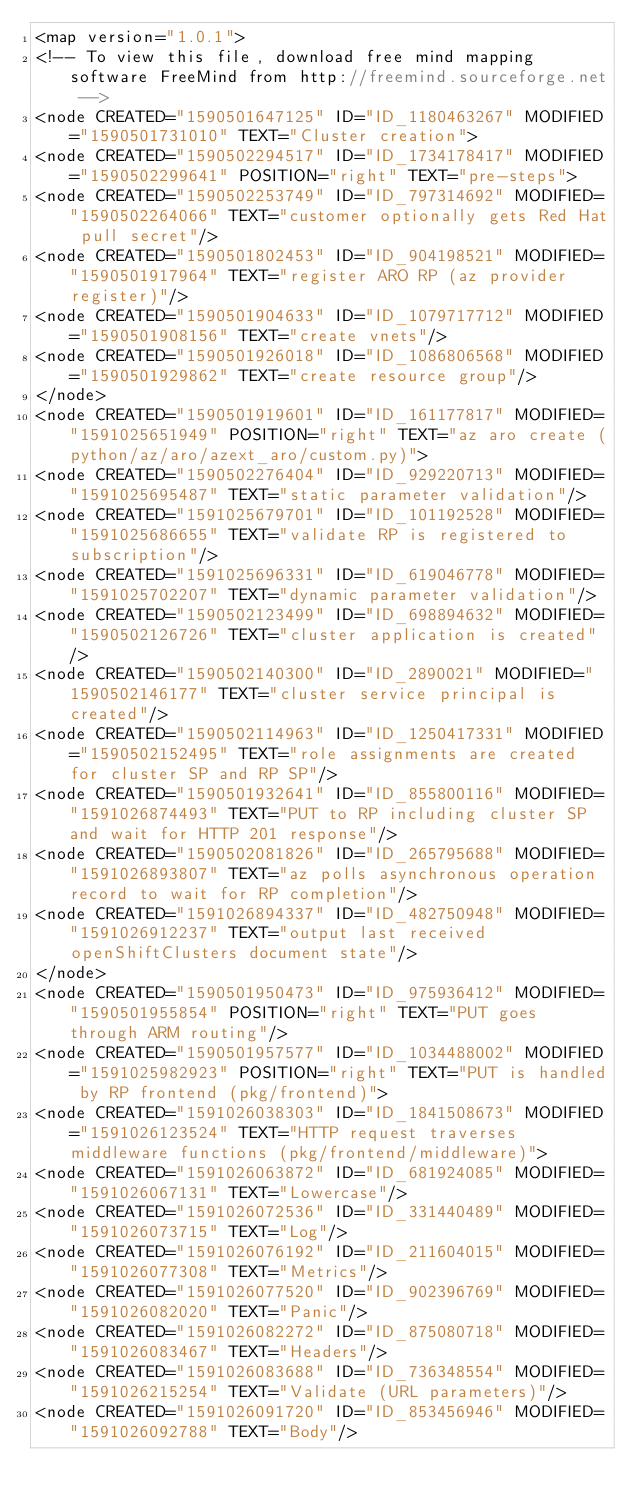<code> <loc_0><loc_0><loc_500><loc_500><_ObjectiveC_><map version="1.0.1">
<!-- To view this file, download free mind mapping software FreeMind from http://freemind.sourceforge.net -->
<node CREATED="1590501647125" ID="ID_1180463267" MODIFIED="1590501731010" TEXT="Cluster creation">
<node CREATED="1590502294517" ID="ID_1734178417" MODIFIED="1590502299641" POSITION="right" TEXT="pre-steps">
<node CREATED="1590502253749" ID="ID_797314692" MODIFIED="1590502264066" TEXT="customer optionally gets Red Hat pull secret"/>
<node CREATED="1590501802453" ID="ID_904198521" MODIFIED="1590501917964" TEXT="register ARO RP (az provider register)"/>
<node CREATED="1590501904633" ID="ID_1079717712" MODIFIED="1590501908156" TEXT="create vnets"/>
<node CREATED="1590501926018" ID="ID_1086806568" MODIFIED="1590501929862" TEXT="create resource group"/>
</node>
<node CREATED="1590501919601" ID="ID_161177817" MODIFIED="1591025651949" POSITION="right" TEXT="az aro create (python/az/aro/azext_aro/custom.py)">
<node CREATED="1590502276404" ID="ID_929220713" MODIFIED="1591025695487" TEXT="static parameter validation"/>
<node CREATED="1591025679701" ID="ID_101192528" MODIFIED="1591025686655" TEXT="validate RP is registered to subscription"/>
<node CREATED="1591025696331" ID="ID_619046778" MODIFIED="1591025702207" TEXT="dynamic parameter validation"/>
<node CREATED="1590502123499" ID="ID_698894632" MODIFIED="1590502126726" TEXT="cluster application is created"/>
<node CREATED="1590502140300" ID="ID_2890021" MODIFIED="1590502146177" TEXT="cluster service principal is created"/>
<node CREATED="1590502114963" ID="ID_1250417331" MODIFIED="1590502152495" TEXT="role assignments are created for cluster SP and RP SP"/>
<node CREATED="1590501932641" ID="ID_855800116" MODIFIED="1591026874493" TEXT="PUT to RP including cluster SP and wait for HTTP 201 response"/>
<node CREATED="1590502081826" ID="ID_265795688" MODIFIED="1591026893807" TEXT="az polls asynchronous operation record to wait for RP completion"/>
<node CREATED="1591026894337" ID="ID_482750948" MODIFIED="1591026912237" TEXT="output last received openShiftClusters document state"/>
</node>
<node CREATED="1590501950473" ID="ID_975936412" MODIFIED="1590501955854" POSITION="right" TEXT="PUT goes through ARM routing"/>
<node CREATED="1590501957577" ID="ID_1034488002" MODIFIED="1591025982923" POSITION="right" TEXT="PUT is handled by RP frontend (pkg/frontend)">
<node CREATED="1591026038303" ID="ID_1841508673" MODIFIED="1591026123524" TEXT="HTTP request traverses middleware functions (pkg/frontend/middleware)">
<node CREATED="1591026063872" ID="ID_681924085" MODIFIED="1591026067131" TEXT="Lowercase"/>
<node CREATED="1591026072536" ID="ID_331440489" MODIFIED="1591026073715" TEXT="Log"/>
<node CREATED="1591026076192" ID="ID_211604015" MODIFIED="1591026077308" TEXT="Metrics"/>
<node CREATED="1591026077520" ID="ID_902396769" MODIFIED="1591026082020" TEXT="Panic"/>
<node CREATED="1591026082272" ID="ID_875080718" MODIFIED="1591026083467" TEXT="Headers"/>
<node CREATED="1591026083688" ID="ID_736348554" MODIFIED="1591026215254" TEXT="Validate (URL parameters)"/>
<node CREATED="1591026091720" ID="ID_853456946" MODIFIED="1591026092788" TEXT="Body"/></code> 